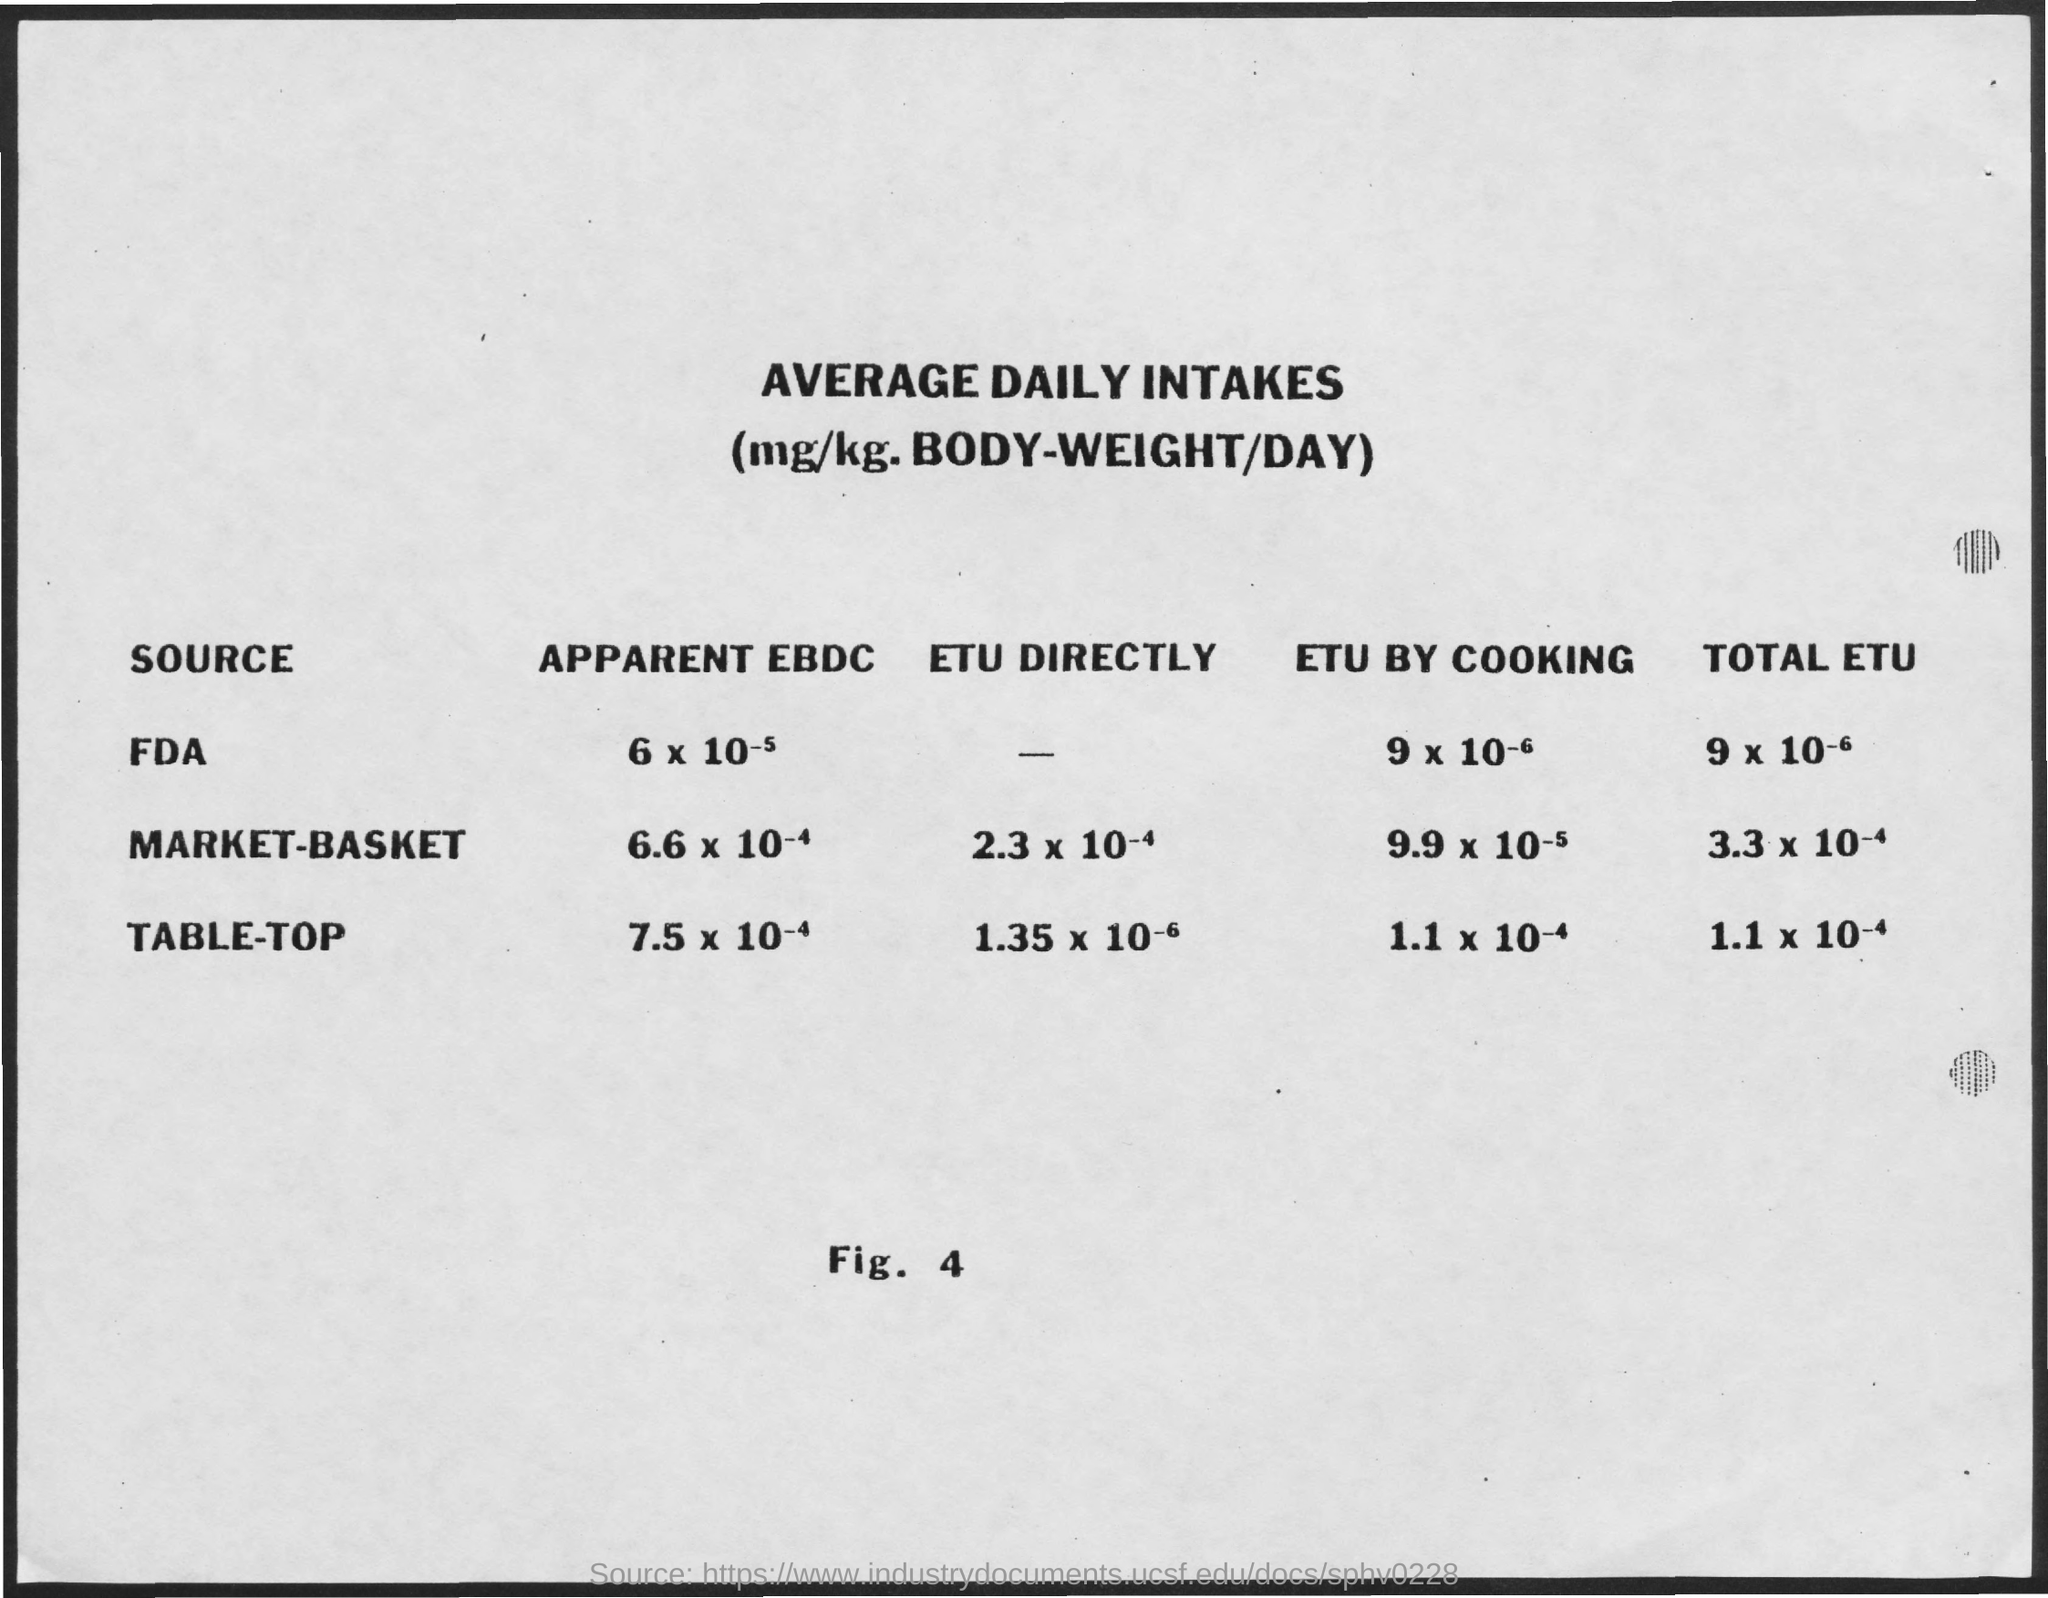Highlight a few significant elements in this photo. The title of the document is 'Average Daily Intakes.' 